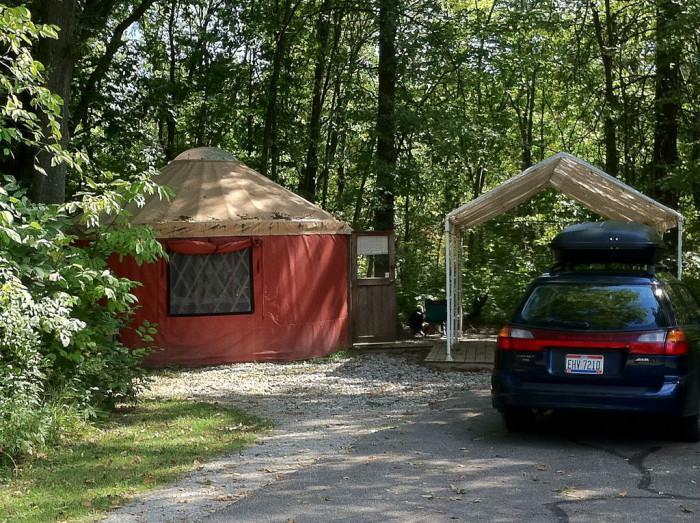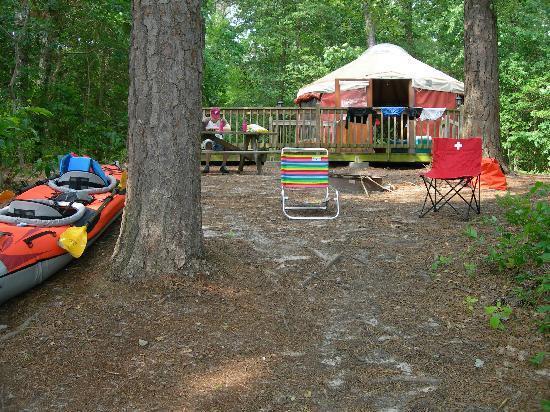The first image is the image on the left, the second image is the image on the right. Considering the images on both sides, is "Multiple lawn chairs are on the ground in front of a round building with a cone-shaped roof." valid? Answer yes or no. Yes. The first image is the image on the left, the second image is the image on the right. Examine the images to the left and right. Is the description "Two yurts are situated in a woody area on square wooden decks with railings, one of them dark green and the other a different color." accurate? Answer yes or no. No. 